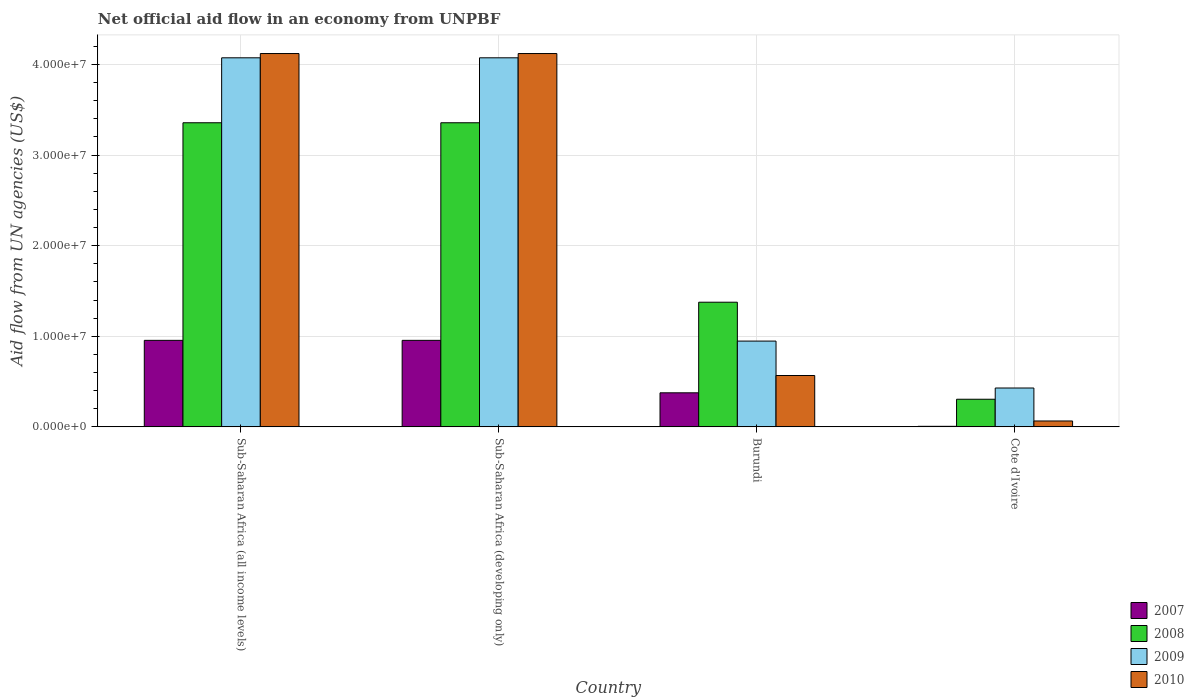How many groups of bars are there?
Ensure brevity in your answer.  4. How many bars are there on the 1st tick from the left?
Ensure brevity in your answer.  4. How many bars are there on the 2nd tick from the right?
Offer a terse response. 4. What is the label of the 3rd group of bars from the left?
Keep it short and to the point. Burundi. In how many cases, is the number of bars for a given country not equal to the number of legend labels?
Your response must be concise. 0. What is the net official aid flow in 2007 in Burundi?
Give a very brief answer. 3.76e+06. Across all countries, what is the maximum net official aid flow in 2007?
Offer a terse response. 9.55e+06. In which country was the net official aid flow in 2007 maximum?
Provide a short and direct response. Sub-Saharan Africa (all income levels). In which country was the net official aid flow in 2010 minimum?
Ensure brevity in your answer.  Cote d'Ivoire. What is the total net official aid flow in 2007 in the graph?
Keep it short and to the point. 2.29e+07. What is the difference between the net official aid flow in 2010 in Burundi and that in Sub-Saharan Africa (developing only)?
Provide a short and direct response. -3.55e+07. What is the difference between the net official aid flow in 2010 in Sub-Saharan Africa (all income levels) and the net official aid flow in 2007 in Sub-Saharan Africa (developing only)?
Keep it short and to the point. 3.17e+07. What is the average net official aid flow in 2009 per country?
Your answer should be compact. 2.38e+07. What is the difference between the net official aid flow of/in 2009 and net official aid flow of/in 2008 in Burundi?
Provide a succinct answer. -4.29e+06. In how many countries, is the net official aid flow in 2008 greater than 2000000 US$?
Offer a very short reply. 4. What is the ratio of the net official aid flow in 2008 in Cote d'Ivoire to that in Sub-Saharan Africa (developing only)?
Your answer should be compact. 0.09. What is the difference between the highest and the second highest net official aid flow in 2008?
Offer a very short reply. 1.98e+07. What is the difference between the highest and the lowest net official aid flow in 2008?
Your response must be concise. 3.05e+07. What does the 2nd bar from the right in Burundi represents?
Give a very brief answer. 2009. Is it the case that in every country, the sum of the net official aid flow in 2007 and net official aid flow in 2008 is greater than the net official aid flow in 2009?
Offer a very short reply. No. Are all the bars in the graph horizontal?
Provide a short and direct response. No. How many countries are there in the graph?
Provide a short and direct response. 4. What is the difference between two consecutive major ticks on the Y-axis?
Give a very brief answer. 1.00e+07. Does the graph contain any zero values?
Your answer should be very brief. No. Does the graph contain grids?
Your response must be concise. Yes. What is the title of the graph?
Your answer should be very brief. Net official aid flow in an economy from UNPBF. What is the label or title of the Y-axis?
Provide a short and direct response. Aid flow from UN agencies (US$). What is the Aid flow from UN agencies (US$) of 2007 in Sub-Saharan Africa (all income levels)?
Your answer should be very brief. 9.55e+06. What is the Aid flow from UN agencies (US$) in 2008 in Sub-Saharan Africa (all income levels)?
Ensure brevity in your answer.  3.36e+07. What is the Aid flow from UN agencies (US$) in 2009 in Sub-Saharan Africa (all income levels)?
Your response must be concise. 4.07e+07. What is the Aid flow from UN agencies (US$) in 2010 in Sub-Saharan Africa (all income levels)?
Offer a terse response. 4.12e+07. What is the Aid flow from UN agencies (US$) in 2007 in Sub-Saharan Africa (developing only)?
Offer a terse response. 9.55e+06. What is the Aid flow from UN agencies (US$) of 2008 in Sub-Saharan Africa (developing only)?
Your answer should be very brief. 3.36e+07. What is the Aid flow from UN agencies (US$) of 2009 in Sub-Saharan Africa (developing only)?
Provide a succinct answer. 4.07e+07. What is the Aid flow from UN agencies (US$) of 2010 in Sub-Saharan Africa (developing only)?
Give a very brief answer. 4.12e+07. What is the Aid flow from UN agencies (US$) in 2007 in Burundi?
Your response must be concise. 3.76e+06. What is the Aid flow from UN agencies (US$) of 2008 in Burundi?
Offer a terse response. 1.38e+07. What is the Aid flow from UN agencies (US$) of 2009 in Burundi?
Provide a succinct answer. 9.47e+06. What is the Aid flow from UN agencies (US$) in 2010 in Burundi?
Give a very brief answer. 5.67e+06. What is the Aid flow from UN agencies (US$) in 2008 in Cote d'Ivoire?
Ensure brevity in your answer.  3.05e+06. What is the Aid flow from UN agencies (US$) in 2009 in Cote d'Ivoire?
Offer a terse response. 4.29e+06. What is the Aid flow from UN agencies (US$) in 2010 in Cote d'Ivoire?
Offer a very short reply. 6.50e+05. Across all countries, what is the maximum Aid flow from UN agencies (US$) in 2007?
Keep it short and to the point. 9.55e+06. Across all countries, what is the maximum Aid flow from UN agencies (US$) in 2008?
Provide a short and direct response. 3.36e+07. Across all countries, what is the maximum Aid flow from UN agencies (US$) of 2009?
Your response must be concise. 4.07e+07. Across all countries, what is the maximum Aid flow from UN agencies (US$) of 2010?
Offer a terse response. 4.12e+07. Across all countries, what is the minimum Aid flow from UN agencies (US$) in 2007?
Offer a very short reply. 6.00e+04. Across all countries, what is the minimum Aid flow from UN agencies (US$) of 2008?
Provide a short and direct response. 3.05e+06. Across all countries, what is the minimum Aid flow from UN agencies (US$) of 2009?
Your answer should be very brief. 4.29e+06. Across all countries, what is the minimum Aid flow from UN agencies (US$) in 2010?
Give a very brief answer. 6.50e+05. What is the total Aid flow from UN agencies (US$) in 2007 in the graph?
Your answer should be compact. 2.29e+07. What is the total Aid flow from UN agencies (US$) of 2008 in the graph?
Your response must be concise. 8.40e+07. What is the total Aid flow from UN agencies (US$) of 2009 in the graph?
Offer a very short reply. 9.52e+07. What is the total Aid flow from UN agencies (US$) of 2010 in the graph?
Give a very brief answer. 8.87e+07. What is the difference between the Aid flow from UN agencies (US$) in 2007 in Sub-Saharan Africa (all income levels) and that in Sub-Saharan Africa (developing only)?
Your response must be concise. 0. What is the difference between the Aid flow from UN agencies (US$) in 2009 in Sub-Saharan Africa (all income levels) and that in Sub-Saharan Africa (developing only)?
Offer a terse response. 0. What is the difference between the Aid flow from UN agencies (US$) in 2007 in Sub-Saharan Africa (all income levels) and that in Burundi?
Keep it short and to the point. 5.79e+06. What is the difference between the Aid flow from UN agencies (US$) of 2008 in Sub-Saharan Africa (all income levels) and that in Burundi?
Provide a succinct answer. 1.98e+07. What is the difference between the Aid flow from UN agencies (US$) of 2009 in Sub-Saharan Africa (all income levels) and that in Burundi?
Your answer should be very brief. 3.13e+07. What is the difference between the Aid flow from UN agencies (US$) of 2010 in Sub-Saharan Africa (all income levels) and that in Burundi?
Offer a terse response. 3.55e+07. What is the difference between the Aid flow from UN agencies (US$) in 2007 in Sub-Saharan Africa (all income levels) and that in Cote d'Ivoire?
Provide a short and direct response. 9.49e+06. What is the difference between the Aid flow from UN agencies (US$) in 2008 in Sub-Saharan Africa (all income levels) and that in Cote d'Ivoire?
Provide a short and direct response. 3.05e+07. What is the difference between the Aid flow from UN agencies (US$) of 2009 in Sub-Saharan Africa (all income levels) and that in Cote d'Ivoire?
Provide a short and direct response. 3.64e+07. What is the difference between the Aid flow from UN agencies (US$) of 2010 in Sub-Saharan Africa (all income levels) and that in Cote d'Ivoire?
Give a very brief answer. 4.06e+07. What is the difference between the Aid flow from UN agencies (US$) in 2007 in Sub-Saharan Africa (developing only) and that in Burundi?
Give a very brief answer. 5.79e+06. What is the difference between the Aid flow from UN agencies (US$) in 2008 in Sub-Saharan Africa (developing only) and that in Burundi?
Your response must be concise. 1.98e+07. What is the difference between the Aid flow from UN agencies (US$) in 2009 in Sub-Saharan Africa (developing only) and that in Burundi?
Your response must be concise. 3.13e+07. What is the difference between the Aid flow from UN agencies (US$) in 2010 in Sub-Saharan Africa (developing only) and that in Burundi?
Keep it short and to the point. 3.55e+07. What is the difference between the Aid flow from UN agencies (US$) in 2007 in Sub-Saharan Africa (developing only) and that in Cote d'Ivoire?
Ensure brevity in your answer.  9.49e+06. What is the difference between the Aid flow from UN agencies (US$) in 2008 in Sub-Saharan Africa (developing only) and that in Cote d'Ivoire?
Offer a terse response. 3.05e+07. What is the difference between the Aid flow from UN agencies (US$) of 2009 in Sub-Saharan Africa (developing only) and that in Cote d'Ivoire?
Ensure brevity in your answer.  3.64e+07. What is the difference between the Aid flow from UN agencies (US$) of 2010 in Sub-Saharan Africa (developing only) and that in Cote d'Ivoire?
Offer a terse response. 4.06e+07. What is the difference between the Aid flow from UN agencies (US$) in 2007 in Burundi and that in Cote d'Ivoire?
Offer a terse response. 3.70e+06. What is the difference between the Aid flow from UN agencies (US$) in 2008 in Burundi and that in Cote d'Ivoire?
Keep it short and to the point. 1.07e+07. What is the difference between the Aid flow from UN agencies (US$) of 2009 in Burundi and that in Cote d'Ivoire?
Keep it short and to the point. 5.18e+06. What is the difference between the Aid flow from UN agencies (US$) in 2010 in Burundi and that in Cote d'Ivoire?
Provide a succinct answer. 5.02e+06. What is the difference between the Aid flow from UN agencies (US$) in 2007 in Sub-Saharan Africa (all income levels) and the Aid flow from UN agencies (US$) in 2008 in Sub-Saharan Africa (developing only)?
Provide a succinct answer. -2.40e+07. What is the difference between the Aid flow from UN agencies (US$) in 2007 in Sub-Saharan Africa (all income levels) and the Aid flow from UN agencies (US$) in 2009 in Sub-Saharan Africa (developing only)?
Make the answer very short. -3.12e+07. What is the difference between the Aid flow from UN agencies (US$) of 2007 in Sub-Saharan Africa (all income levels) and the Aid flow from UN agencies (US$) of 2010 in Sub-Saharan Africa (developing only)?
Keep it short and to the point. -3.17e+07. What is the difference between the Aid flow from UN agencies (US$) of 2008 in Sub-Saharan Africa (all income levels) and the Aid flow from UN agencies (US$) of 2009 in Sub-Saharan Africa (developing only)?
Ensure brevity in your answer.  -7.17e+06. What is the difference between the Aid flow from UN agencies (US$) in 2008 in Sub-Saharan Africa (all income levels) and the Aid flow from UN agencies (US$) in 2010 in Sub-Saharan Africa (developing only)?
Provide a short and direct response. -7.64e+06. What is the difference between the Aid flow from UN agencies (US$) of 2009 in Sub-Saharan Africa (all income levels) and the Aid flow from UN agencies (US$) of 2010 in Sub-Saharan Africa (developing only)?
Make the answer very short. -4.70e+05. What is the difference between the Aid flow from UN agencies (US$) of 2007 in Sub-Saharan Africa (all income levels) and the Aid flow from UN agencies (US$) of 2008 in Burundi?
Your response must be concise. -4.21e+06. What is the difference between the Aid flow from UN agencies (US$) of 2007 in Sub-Saharan Africa (all income levels) and the Aid flow from UN agencies (US$) of 2009 in Burundi?
Your response must be concise. 8.00e+04. What is the difference between the Aid flow from UN agencies (US$) of 2007 in Sub-Saharan Africa (all income levels) and the Aid flow from UN agencies (US$) of 2010 in Burundi?
Offer a terse response. 3.88e+06. What is the difference between the Aid flow from UN agencies (US$) of 2008 in Sub-Saharan Africa (all income levels) and the Aid flow from UN agencies (US$) of 2009 in Burundi?
Offer a very short reply. 2.41e+07. What is the difference between the Aid flow from UN agencies (US$) in 2008 in Sub-Saharan Africa (all income levels) and the Aid flow from UN agencies (US$) in 2010 in Burundi?
Give a very brief answer. 2.79e+07. What is the difference between the Aid flow from UN agencies (US$) of 2009 in Sub-Saharan Africa (all income levels) and the Aid flow from UN agencies (US$) of 2010 in Burundi?
Keep it short and to the point. 3.51e+07. What is the difference between the Aid flow from UN agencies (US$) in 2007 in Sub-Saharan Africa (all income levels) and the Aid flow from UN agencies (US$) in 2008 in Cote d'Ivoire?
Your answer should be compact. 6.50e+06. What is the difference between the Aid flow from UN agencies (US$) in 2007 in Sub-Saharan Africa (all income levels) and the Aid flow from UN agencies (US$) in 2009 in Cote d'Ivoire?
Keep it short and to the point. 5.26e+06. What is the difference between the Aid flow from UN agencies (US$) in 2007 in Sub-Saharan Africa (all income levels) and the Aid flow from UN agencies (US$) in 2010 in Cote d'Ivoire?
Your answer should be very brief. 8.90e+06. What is the difference between the Aid flow from UN agencies (US$) of 2008 in Sub-Saharan Africa (all income levels) and the Aid flow from UN agencies (US$) of 2009 in Cote d'Ivoire?
Ensure brevity in your answer.  2.93e+07. What is the difference between the Aid flow from UN agencies (US$) of 2008 in Sub-Saharan Africa (all income levels) and the Aid flow from UN agencies (US$) of 2010 in Cote d'Ivoire?
Ensure brevity in your answer.  3.29e+07. What is the difference between the Aid flow from UN agencies (US$) in 2009 in Sub-Saharan Africa (all income levels) and the Aid flow from UN agencies (US$) in 2010 in Cote d'Ivoire?
Your answer should be very brief. 4.01e+07. What is the difference between the Aid flow from UN agencies (US$) in 2007 in Sub-Saharan Africa (developing only) and the Aid flow from UN agencies (US$) in 2008 in Burundi?
Ensure brevity in your answer.  -4.21e+06. What is the difference between the Aid flow from UN agencies (US$) of 2007 in Sub-Saharan Africa (developing only) and the Aid flow from UN agencies (US$) of 2009 in Burundi?
Offer a very short reply. 8.00e+04. What is the difference between the Aid flow from UN agencies (US$) in 2007 in Sub-Saharan Africa (developing only) and the Aid flow from UN agencies (US$) in 2010 in Burundi?
Your response must be concise. 3.88e+06. What is the difference between the Aid flow from UN agencies (US$) of 2008 in Sub-Saharan Africa (developing only) and the Aid flow from UN agencies (US$) of 2009 in Burundi?
Ensure brevity in your answer.  2.41e+07. What is the difference between the Aid flow from UN agencies (US$) of 2008 in Sub-Saharan Africa (developing only) and the Aid flow from UN agencies (US$) of 2010 in Burundi?
Your answer should be compact. 2.79e+07. What is the difference between the Aid flow from UN agencies (US$) in 2009 in Sub-Saharan Africa (developing only) and the Aid flow from UN agencies (US$) in 2010 in Burundi?
Your response must be concise. 3.51e+07. What is the difference between the Aid flow from UN agencies (US$) of 2007 in Sub-Saharan Africa (developing only) and the Aid flow from UN agencies (US$) of 2008 in Cote d'Ivoire?
Provide a short and direct response. 6.50e+06. What is the difference between the Aid flow from UN agencies (US$) of 2007 in Sub-Saharan Africa (developing only) and the Aid flow from UN agencies (US$) of 2009 in Cote d'Ivoire?
Your answer should be compact. 5.26e+06. What is the difference between the Aid flow from UN agencies (US$) in 2007 in Sub-Saharan Africa (developing only) and the Aid flow from UN agencies (US$) in 2010 in Cote d'Ivoire?
Offer a very short reply. 8.90e+06. What is the difference between the Aid flow from UN agencies (US$) of 2008 in Sub-Saharan Africa (developing only) and the Aid flow from UN agencies (US$) of 2009 in Cote d'Ivoire?
Your answer should be compact. 2.93e+07. What is the difference between the Aid flow from UN agencies (US$) in 2008 in Sub-Saharan Africa (developing only) and the Aid flow from UN agencies (US$) in 2010 in Cote d'Ivoire?
Your answer should be compact. 3.29e+07. What is the difference between the Aid flow from UN agencies (US$) of 2009 in Sub-Saharan Africa (developing only) and the Aid flow from UN agencies (US$) of 2010 in Cote d'Ivoire?
Make the answer very short. 4.01e+07. What is the difference between the Aid flow from UN agencies (US$) in 2007 in Burundi and the Aid flow from UN agencies (US$) in 2008 in Cote d'Ivoire?
Offer a terse response. 7.10e+05. What is the difference between the Aid flow from UN agencies (US$) in 2007 in Burundi and the Aid flow from UN agencies (US$) in 2009 in Cote d'Ivoire?
Your response must be concise. -5.30e+05. What is the difference between the Aid flow from UN agencies (US$) of 2007 in Burundi and the Aid flow from UN agencies (US$) of 2010 in Cote d'Ivoire?
Your response must be concise. 3.11e+06. What is the difference between the Aid flow from UN agencies (US$) of 2008 in Burundi and the Aid flow from UN agencies (US$) of 2009 in Cote d'Ivoire?
Offer a very short reply. 9.47e+06. What is the difference between the Aid flow from UN agencies (US$) of 2008 in Burundi and the Aid flow from UN agencies (US$) of 2010 in Cote d'Ivoire?
Provide a succinct answer. 1.31e+07. What is the difference between the Aid flow from UN agencies (US$) of 2009 in Burundi and the Aid flow from UN agencies (US$) of 2010 in Cote d'Ivoire?
Ensure brevity in your answer.  8.82e+06. What is the average Aid flow from UN agencies (US$) of 2007 per country?
Provide a short and direct response. 5.73e+06. What is the average Aid flow from UN agencies (US$) of 2008 per country?
Your response must be concise. 2.10e+07. What is the average Aid flow from UN agencies (US$) in 2009 per country?
Make the answer very short. 2.38e+07. What is the average Aid flow from UN agencies (US$) in 2010 per country?
Your answer should be compact. 2.22e+07. What is the difference between the Aid flow from UN agencies (US$) in 2007 and Aid flow from UN agencies (US$) in 2008 in Sub-Saharan Africa (all income levels)?
Your response must be concise. -2.40e+07. What is the difference between the Aid flow from UN agencies (US$) of 2007 and Aid flow from UN agencies (US$) of 2009 in Sub-Saharan Africa (all income levels)?
Make the answer very short. -3.12e+07. What is the difference between the Aid flow from UN agencies (US$) in 2007 and Aid flow from UN agencies (US$) in 2010 in Sub-Saharan Africa (all income levels)?
Keep it short and to the point. -3.17e+07. What is the difference between the Aid flow from UN agencies (US$) of 2008 and Aid flow from UN agencies (US$) of 2009 in Sub-Saharan Africa (all income levels)?
Ensure brevity in your answer.  -7.17e+06. What is the difference between the Aid flow from UN agencies (US$) of 2008 and Aid flow from UN agencies (US$) of 2010 in Sub-Saharan Africa (all income levels)?
Your answer should be compact. -7.64e+06. What is the difference between the Aid flow from UN agencies (US$) of 2009 and Aid flow from UN agencies (US$) of 2010 in Sub-Saharan Africa (all income levels)?
Your answer should be compact. -4.70e+05. What is the difference between the Aid flow from UN agencies (US$) in 2007 and Aid flow from UN agencies (US$) in 2008 in Sub-Saharan Africa (developing only)?
Provide a succinct answer. -2.40e+07. What is the difference between the Aid flow from UN agencies (US$) of 2007 and Aid flow from UN agencies (US$) of 2009 in Sub-Saharan Africa (developing only)?
Your answer should be compact. -3.12e+07. What is the difference between the Aid flow from UN agencies (US$) in 2007 and Aid flow from UN agencies (US$) in 2010 in Sub-Saharan Africa (developing only)?
Keep it short and to the point. -3.17e+07. What is the difference between the Aid flow from UN agencies (US$) in 2008 and Aid flow from UN agencies (US$) in 2009 in Sub-Saharan Africa (developing only)?
Your answer should be compact. -7.17e+06. What is the difference between the Aid flow from UN agencies (US$) of 2008 and Aid flow from UN agencies (US$) of 2010 in Sub-Saharan Africa (developing only)?
Provide a succinct answer. -7.64e+06. What is the difference between the Aid flow from UN agencies (US$) of 2009 and Aid flow from UN agencies (US$) of 2010 in Sub-Saharan Africa (developing only)?
Give a very brief answer. -4.70e+05. What is the difference between the Aid flow from UN agencies (US$) of 2007 and Aid flow from UN agencies (US$) of 2008 in Burundi?
Provide a succinct answer. -1.00e+07. What is the difference between the Aid flow from UN agencies (US$) in 2007 and Aid flow from UN agencies (US$) in 2009 in Burundi?
Give a very brief answer. -5.71e+06. What is the difference between the Aid flow from UN agencies (US$) in 2007 and Aid flow from UN agencies (US$) in 2010 in Burundi?
Your response must be concise. -1.91e+06. What is the difference between the Aid flow from UN agencies (US$) in 2008 and Aid flow from UN agencies (US$) in 2009 in Burundi?
Keep it short and to the point. 4.29e+06. What is the difference between the Aid flow from UN agencies (US$) in 2008 and Aid flow from UN agencies (US$) in 2010 in Burundi?
Your answer should be compact. 8.09e+06. What is the difference between the Aid flow from UN agencies (US$) of 2009 and Aid flow from UN agencies (US$) of 2010 in Burundi?
Your response must be concise. 3.80e+06. What is the difference between the Aid flow from UN agencies (US$) of 2007 and Aid flow from UN agencies (US$) of 2008 in Cote d'Ivoire?
Offer a terse response. -2.99e+06. What is the difference between the Aid flow from UN agencies (US$) of 2007 and Aid flow from UN agencies (US$) of 2009 in Cote d'Ivoire?
Ensure brevity in your answer.  -4.23e+06. What is the difference between the Aid flow from UN agencies (US$) in 2007 and Aid flow from UN agencies (US$) in 2010 in Cote d'Ivoire?
Provide a succinct answer. -5.90e+05. What is the difference between the Aid flow from UN agencies (US$) of 2008 and Aid flow from UN agencies (US$) of 2009 in Cote d'Ivoire?
Your answer should be very brief. -1.24e+06. What is the difference between the Aid flow from UN agencies (US$) in 2008 and Aid flow from UN agencies (US$) in 2010 in Cote d'Ivoire?
Your response must be concise. 2.40e+06. What is the difference between the Aid flow from UN agencies (US$) of 2009 and Aid flow from UN agencies (US$) of 2010 in Cote d'Ivoire?
Provide a short and direct response. 3.64e+06. What is the ratio of the Aid flow from UN agencies (US$) of 2009 in Sub-Saharan Africa (all income levels) to that in Sub-Saharan Africa (developing only)?
Provide a short and direct response. 1. What is the ratio of the Aid flow from UN agencies (US$) in 2007 in Sub-Saharan Africa (all income levels) to that in Burundi?
Provide a short and direct response. 2.54. What is the ratio of the Aid flow from UN agencies (US$) in 2008 in Sub-Saharan Africa (all income levels) to that in Burundi?
Your answer should be compact. 2.44. What is the ratio of the Aid flow from UN agencies (US$) in 2009 in Sub-Saharan Africa (all income levels) to that in Burundi?
Offer a very short reply. 4.3. What is the ratio of the Aid flow from UN agencies (US$) in 2010 in Sub-Saharan Africa (all income levels) to that in Burundi?
Make the answer very short. 7.27. What is the ratio of the Aid flow from UN agencies (US$) in 2007 in Sub-Saharan Africa (all income levels) to that in Cote d'Ivoire?
Provide a succinct answer. 159.17. What is the ratio of the Aid flow from UN agencies (US$) of 2008 in Sub-Saharan Africa (all income levels) to that in Cote d'Ivoire?
Ensure brevity in your answer.  11.01. What is the ratio of the Aid flow from UN agencies (US$) of 2009 in Sub-Saharan Africa (all income levels) to that in Cote d'Ivoire?
Offer a very short reply. 9.5. What is the ratio of the Aid flow from UN agencies (US$) of 2010 in Sub-Saharan Africa (all income levels) to that in Cote d'Ivoire?
Offer a very short reply. 63.4. What is the ratio of the Aid flow from UN agencies (US$) in 2007 in Sub-Saharan Africa (developing only) to that in Burundi?
Provide a succinct answer. 2.54. What is the ratio of the Aid flow from UN agencies (US$) of 2008 in Sub-Saharan Africa (developing only) to that in Burundi?
Your response must be concise. 2.44. What is the ratio of the Aid flow from UN agencies (US$) of 2009 in Sub-Saharan Africa (developing only) to that in Burundi?
Provide a short and direct response. 4.3. What is the ratio of the Aid flow from UN agencies (US$) of 2010 in Sub-Saharan Africa (developing only) to that in Burundi?
Give a very brief answer. 7.27. What is the ratio of the Aid flow from UN agencies (US$) in 2007 in Sub-Saharan Africa (developing only) to that in Cote d'Ivoire?
Give a very brief answer. 159.17. What is the ratio of the Aid flow from UN agencies (US$) in 2008 in Sub-Saharan Africa (developing only) to that in Cote d'Ivoire?
Ensure brevity in your answer.  11.01. What is the ratio of the Aid flow from UN agencies (US$) of 2009 in Sub-Saharan Africa (developing only) to that in Cote d'Ivoire?
Give a very brief answer. 9.5. What is the ratio of the Aid flow from UN agencies (US$) of 2010 in Sub-Saharan Africa (developing only) to that in Cote d'Ivoire?
Keep it short and to the point. 63.4. What is the ratio of the Aid flow from UN agencies (US$) in 2007 in Burundi to that in Cote d'Ivoire?
Offer a very short reply. 62.67. What is the ratio of the Aid flow from UN agencies (US$) in 2008 in Burundi to that in Cote d'Ivoire?
Offer a very short reply. 4.51. What is the ratio of the Aid flow from UN agencies (US$) of 2009 in Burundi to that in Cote d'Ivoire?
Give a very brief answer. 2.21. What is the ratio of the Aid flow from UN agencies (US$) in 2010 in Burundi to that in Cote d'Ivoire?
Offer a terse response. 8.72. What is the difference between the highest and the second highest Aid flow from UN agencies (US$) of 2008?
Offer a very short reply. 0. What is the difference between the highest and the second highest Aid flow from UN agencies (US$) in 2009?
Your response must be concise. 0. What is the difference between the highest and the lowest Aid flow from UN agencies (US$) of 2007?
Provide a short and direct response. 9.49e+06. What is the difference between the highest and the lowest Aid flow from UN agencies (US$) in 2008?
Keep it short and to the point. 3.05e+07. What is the difference between the highest and the lowest Aid flow from UN agencies (US$) of 2009?
Your answer should be very brief. 3.64e+07. What is the difference between the highest and the lowest Aid flow from UN agencies (US$) of 2010?
Offer a very short reply. 4.06e+07. 